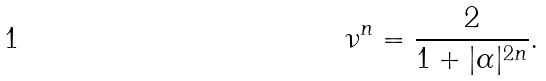Convert formula to latex. <formula><loc_0><loc_0><loc_500><loc_500>\nu ^ { n } = \frac { 2 } { 1 + | \alpha | ^ { 2 n } } .</formula> 